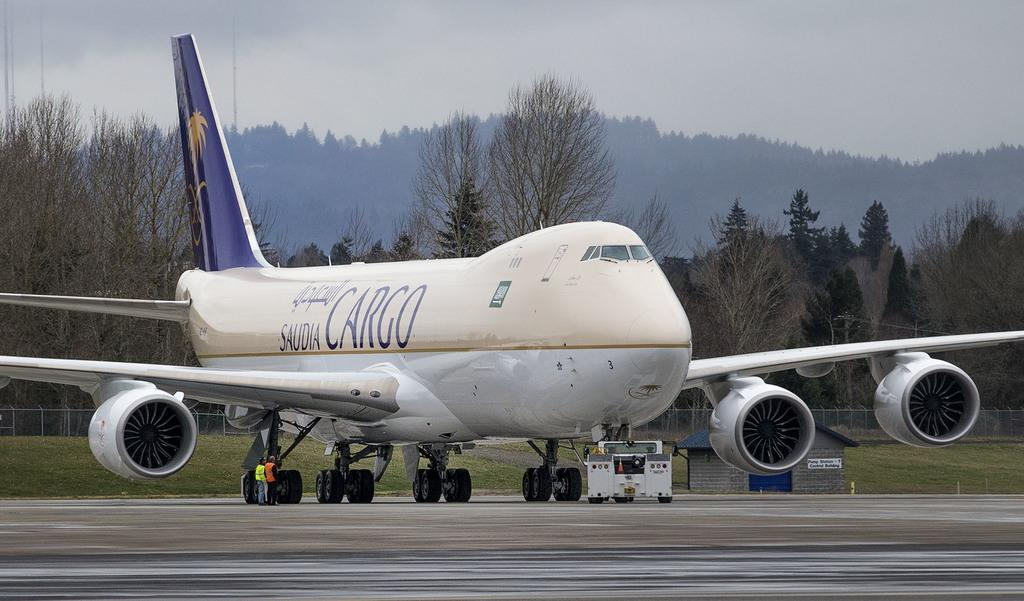<image>
Render a clear and concise summary of the photo. A Saudia Cargo airplane sits on a runway with trees and mountains in the background. 